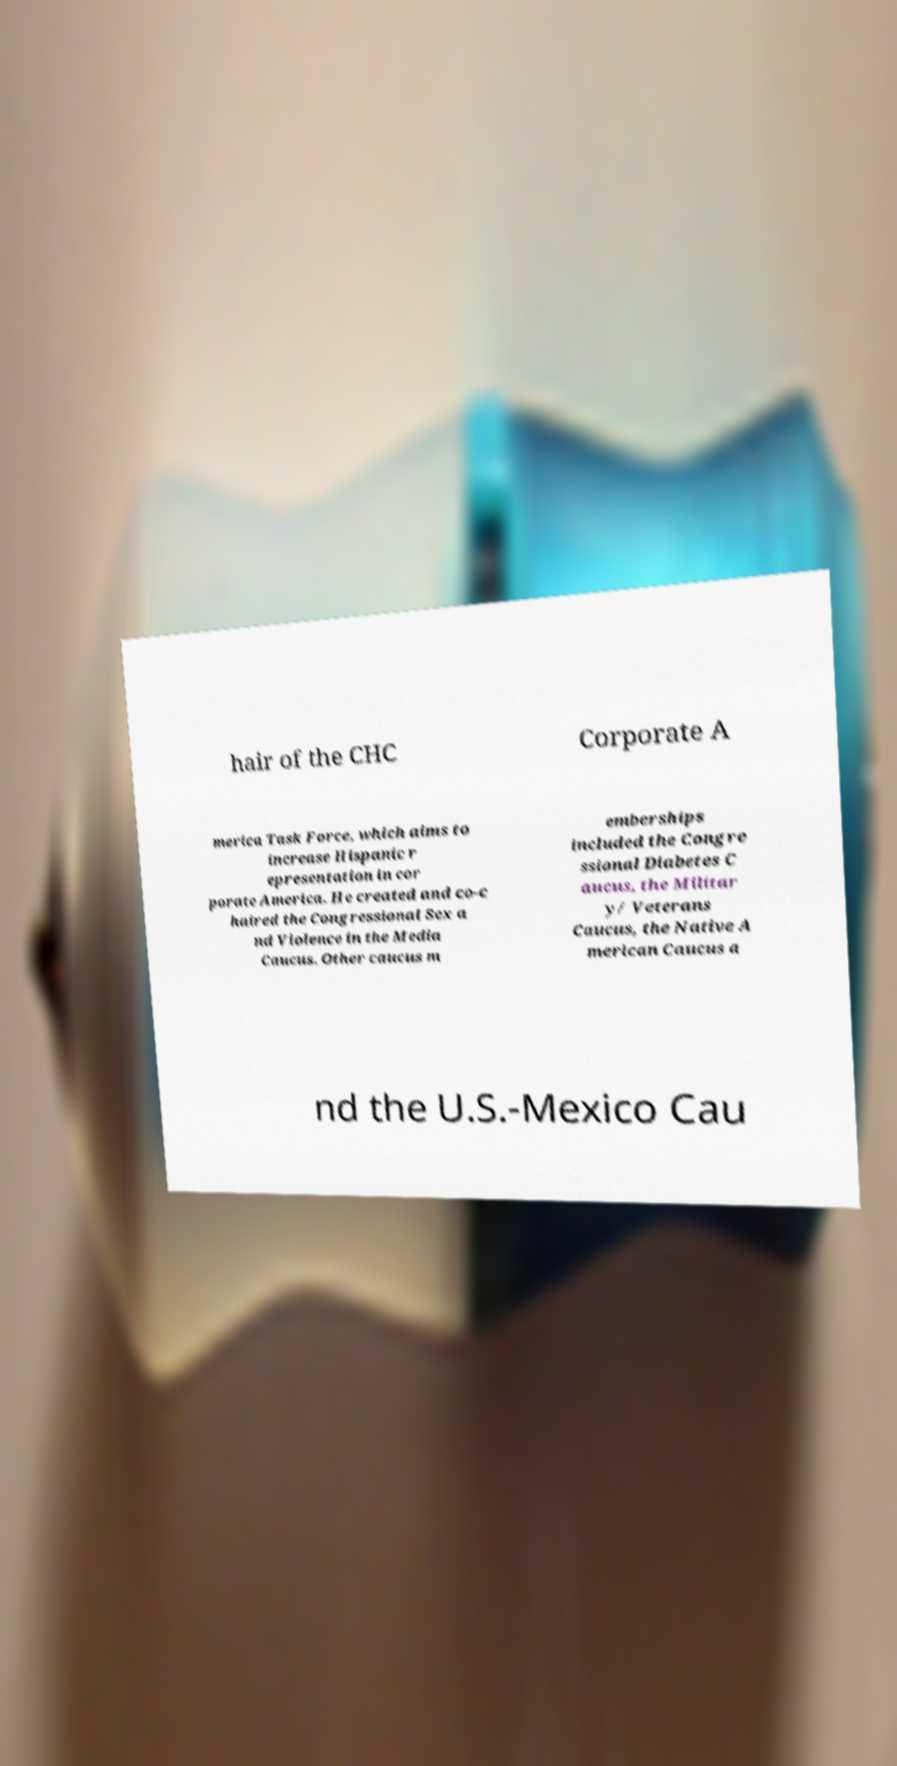Can you accurately transcribe the text from the provided image for me? hair of the CHC Corporate A merica Task Force, which aims to increase Hispanic r epresentation in cor porate America. He created and co-c haired the Congressional Sex a nd Violence in the Media Caucus. Other caucus m emberships included the Congre ssional Diabetes C aucus, the Militar y/ Veterans Caucus, the Native A merican Caucus a nd the U.S.-Mexico Cau 